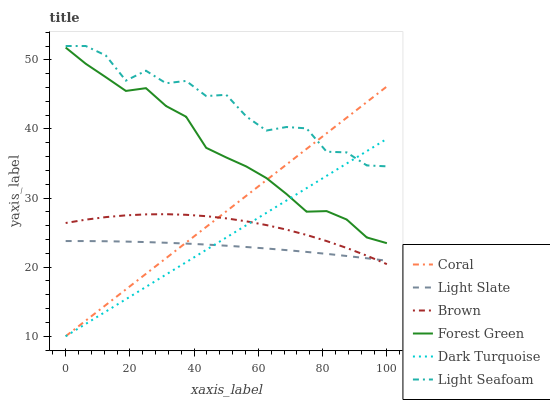Does Light Slate have the minimum area under the curve?
Answer yes or no. Yes. Does Light Seafoam have the maximum area under the curve?
Answer yes or no. Yes. Does Dark Turquoise have the minimum area under the curve?
Answer yes or no. No. Does Dark Turquoise have the maximum area under the curve?
Answer yes or no. No. Is Coral the smoothest?
Answer yes or no. Yes. Is Light Seafoam the roughest?
Answer yes or no. Yes. Is Light Slate the smoothest?
Answer yes or no. No. Is Light Slate the roughest?
Answer yes or no. No. Does Dark Turquoise have the lowest value?
Answer yes or no. Yes. Does Light Slate have the lowest value?
Answer yes or no. No. Does Light Seafoam have the highest value?
Answer yes or no. Yes. Does Dark Turquoise have the highest value?
Answer yes or no. No. Is Light Slate less than Light Seafoam?
Answer yes or no. Yes. Is Light Seafoam greater than Brown?
Answer yes or no. Yes. Does Coral intersect Dark Turquoise?
Answer yes or no. Yes. Is Coral less than Dark Turquoise?
Answer yes or no. No. Is Coral greater than Dark Turquoise?
Answer yes or no. No. Does Light Slate intersect Light Seafoam?
Answer yes or no. No. 